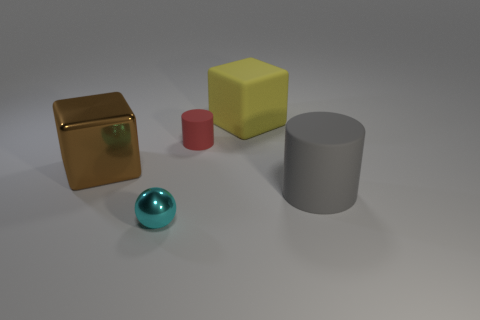Add 3 yellow matte spheres. How many objects exist? 8 Subtract all green metal blocks. Subtract all small spheres. How many objects are left? 4 Add 2 small objects. How many small objects are left? 4 Add 4 small red blocks. How many small red blocks exist? 4 Subtract 0 blue cubes. How many objects are left? 5 Subtract all cubes. How many objects are left? 3 Subtract all red cubes. Subtract all blue balls. How many cubes are left? 2 